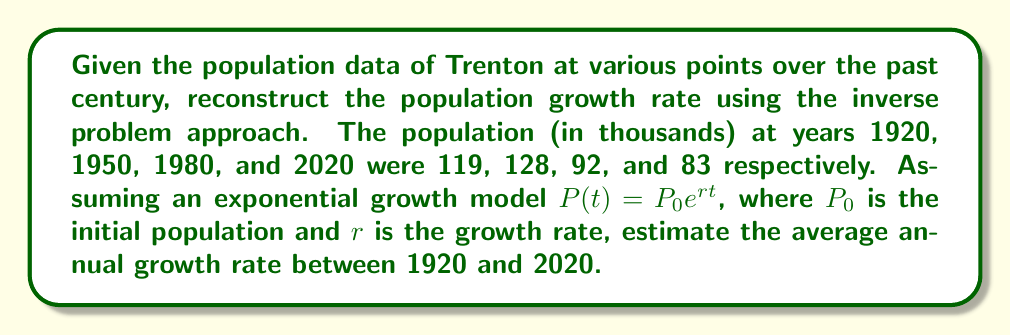Give your solution to this math problem. 1. Let's use the exponential growth model: $P(t) = P_0e^{rt}$

2. We have two data points to use: 1920 (t=0) and 2020 (t=100)
   $P_0 = 119$ (population in 1920)
   $P_{100} = 83$ (population in 2020)

3. Plug these into the equation:
   $83 = 119e^{100r}$

4. Divide both sides by 119:
   $\frac{83}{119} = e^{100r}$

5. Take the natural log of both sides:
   $\ln(\frac{83}{119}) = 100r$

6. Solve for r:
   $r = \frac{\ln(\frac{83}{119})}{100}$

7. Calculate:
   $r = \frac{\ln(0.6974789915966386)}{100} \approx -0.003596$

8. Convert to a percentage:
   $-0.003596 * 100 \approx -0.3596\%$

This negative growth rate indicates a population decline over the century.
Answer: $-0.3596\%$ per year 